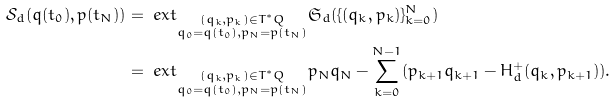<formula> <loc_0><loc_0><loc_500><loc_500>\mathcal { S } _ { d } ( q ( t _ { 0 } ) , p ( t _ { N } ) ) & = \ e x t _ { \substack { ( q _ { k } , p _ { k } ) \in T ^ { * } Q \\ q _ { 0 } = q ( t _ { 0 } ) , p _ { N } = p ( t _ { N } ) } } \mathfrak { S } _ { d } ( \{ ( q _ { k } , p _ { k } ) \} _ { k = 0 } ^ { N } ) \\ & = \ e x t _ { \substack { ( q _ { k } , p _ { k } ) \in T ^ { * } Q \\ q _ { 0 } = q ( t _ { 0 } ) , p _ { N } = p ( t _ { N } ) } } p _ { N } q _ { N } - \sum _ { k = 0 } ^ { N - 1 } ( p _ { k + 1 } q _ { k + 1 } - H _ { d } ^ { + } ( q _ { k } , p _ { k + 1 } ) ) .</formula> 